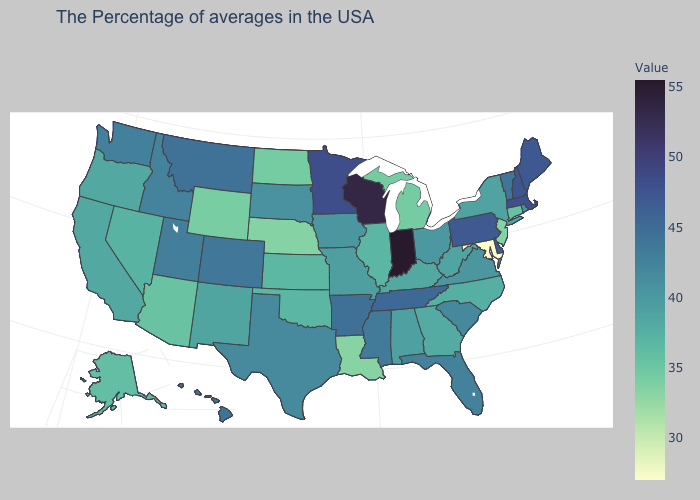Among the states that border Montana , does Wyoming have the lowest value?
Give a very brief answer. Yes. Which states have the highest value in the USA?
Keep it brief. Indiana. Among the states that border Virginia , which have the highest value?
Give a very brief answer. Tennessee. Does Illinois have the highest value in the MidWest?
Be succinct. No. Among the states that border Florida , does Georgia have the lowest value?
Short answer required. Yes. Is the legend a continuous bar?
Keep it brief. Yes. Among the states that border New Mexico , does Arizona have the lowest value?
Keep it brief. Yes. Which states have the highest value in the USA?
Short answer required. Indiana. Is the legend a continuous bar?
Concise answer only. Yes. 